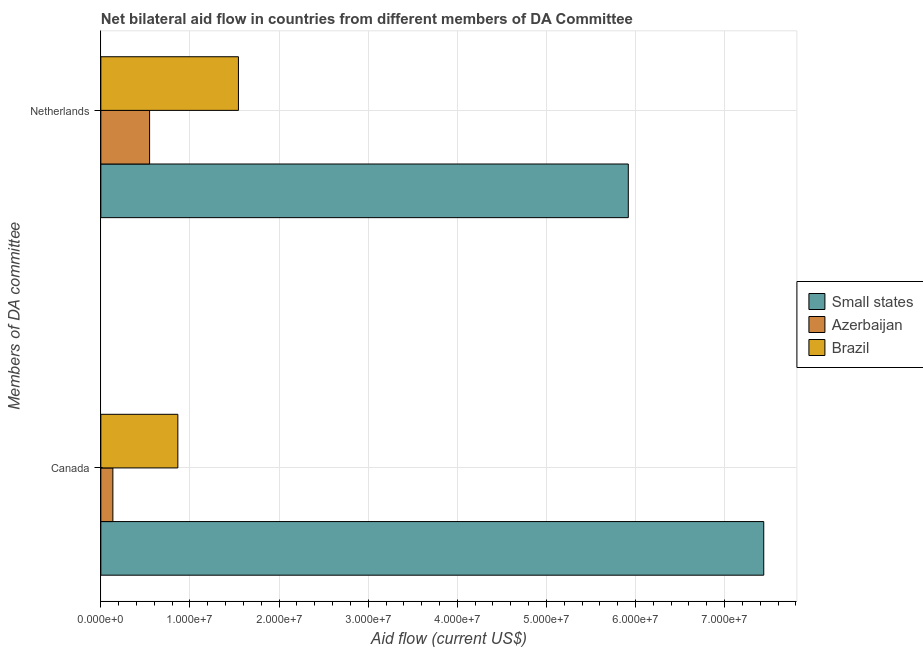Are the number of bars per tick equal to the number of legend labels?
Provide a short and direct response. Yes. Are the number of bars on each tick of the Y-axis equal?
Give a very brief answer. Yes. How many bars are there on the 2nd tick from the bottom?
Your answer should be compact. 3. What is the label of the 1st group of bars from the top?
Offer a terse response. Netherlands. What is the amount of aid given by netherlands in Small states?
Give a very brief answer. 5.92e+07. Across all countries, what is the maximum amount of aid given by netherlands?
Provide a short and direct response. 5.92e+07. Across all countries, what is the minimum amount of aid given by netherlands?
Offer a terse response. 5.47e+06. In which country was the amount of aid given by netherlands maximum?
Ensure brevity in your answer.  Small states. In which country was the amount of aid given by canada minimum?
Offer a terse response. Azerbaijan. What is the total amount of aid given by netherlands in the graph?
Offer a terse response. 8.01e+07. What is the difference between the amount of aid given by netherlands in Azerbaijan and that in Small states?
Your answer should be very brief. -5.37e+07. What is the difference between the amount of aid given by canada in Brazil and the amount of aid given by netherlands in Azerbaijan?
Provide a short and direct response. 3.17e+06. What is the average amount of aid given by canada per country?
Your answer should be very brief. 2.81e+07. What is the difference between the amount of aid given by canada and amount of aid given by netherlands in Azerbaijan?
Offer a very short reply. -4.12e+06. In how many countries, is the amount of aid given by netherlands greater than 26000000 US$?
Your answer should be very brief. 1. What is the ratio of the amount of aid given by canada in Small states to that in Azerbaijan?
Your response must be concise. 55.1. Is the amount of aid given by canada in Brazil less than that in Small states?
Ensure brevity in your answer.  Yes. In how many countries, is the amount of aid given by netherlands greater than the average amount of aid given by netherlands taken over all countries?
Offer a terse response. 1. What does the 2nd bar from the top in Canada represents?
Your response must be concise. Azerbaijan. What does the 2nd bar from the bottom in Canada represents?
Provide a succinct answer. Azerbaijan. How many bars are there?
Keep it short and to the point. 6. What is the difference between two consecutive major ticks on the X-axis?
Keep it short and to the point. 1.00e+07. Are the values on the major ticks of X-axis written in scientific E-notation?
Offer a very short reply. Yes. Where does the legend appear in the graph?
Keep it short and to the point. Center right. How are the legend labels stacked?
Ensure brevity in your answer.  Vertical. What is the title of the graph?
Make the answer very short. Net bilateral aid flow in countries from different members of DA Committee. What is the label or title of the Y-axis?
Your answer should be very brief. Members of DA committee. What is the Aid flow (current US$) in Small states in Canada?
Your answer should be compact. 7.44e+07. What is the Aid flow (current US$) in Azerbaijan in Canada?
Ensure brevity in your answer.  1.35e+06. What is the Aid flow (current US$) of Brazil in Canada?
Provide a succinct answer. 8.64e+06. What is the Aid flow (current US$) in Small states in Netherlands?
Your answer should be compact. 5.92e+07. What is the Aid flow (current US$) of Azerbaijan in Netherlands?
Offer a terse response. 5.47e+06. What is the Aid flow (current US$) in Brazil in Netherlands?
Provide a succinct answer. 1.54e+07. Across all Members of DA committee, what is the maximum Aid flow (current US$) of Small states?
Offer a terse response. 7.44e+07. Across all Members of DA committee, what is the maximum Aid flow (current US$) of Azerbaijan?
Keep it short and to the point. 5.47e+06. Across all Members of DA committee, what is the maximum Aid flow (current US$) of Brazil?
Offer a terse response. 1.54e+07. Across all Members of DA committee, what is the minimum Aid flow (current US$) of Small states?
Provide a short and direct response. 5.92e+07. Across all Members of DA committee, what is the minimum Aid flow (current US$) in Azerbaijan?
Provide a short and direct response. 1.35e+06. Across all Members of DA committee, what is the minimum Aid flow (current US$) in Brazil?
Your response must be concise. 8.64e+06. What is the total Aid flow (current US$) in Small states in the graph?
Your answer should be compact. 1.34e+08. What is the total Aid flow (current US$) of Azerbaijan in the graph?
Provide a short and direct response. 6.82e+06. What is the total Aid flow (current US$) in Brazil in the graph?
Give a very brief answer. 2.41e+07. What is the difference between the Aid flow (current US$) in Small states in Canada and that in Netherlands?
Keep it short and to the point. 1.52e+07. What is the difference between the Aid flow (current US$) in Azerbaijan in Canada and that in Netherlands?
Your answer should be very brief. -4.12e+06. What is the difference between the Aid flow (current US$) in Brazil in Canada and that in Netherlands?
Your answer should be compact. -6.80e+06. What is the difference between the Aid flow (current US$) of Small states in Canada and the Aid flow (current US$) of Azerbaijan in Netherlands?
Offer a terse response. 6.89e+07. What is the difference between the Aid flow (current US$) in Small states in Canada and the Aid flow (current US$) in Brazil in Netherlands?
Your answer should be very brief. 5.90e+07. What is the difference between the Aid flow (current US$) of Azerbaijan in Canada and the Aid flow (current US$) of Brazil in Netherlands?
Provide a succinct answer. -1.41e+07. What is the average Aid flow (current US$) of Small states per Members of DA committee?
Your answer should be compact. 6.68e+07. What is the average Aid flow (current US$) of Azerbaijan per Members of DA committee?
Make the answer very short. 3.41e+06. What is the average Aid flow (current US$) in Brazil per Members of DA committee?
Your answer should be very brief. 1.20e+07. What is the difference between the Aid flow (current US$) of Small states and Aid flow (current US$) of Azerbaijan in Canada?
Your answer should be compact. 7.30e+07. What is the difference between the Aid flow (current US$) of Small states and Aid flow (current US$) of Brazil in Canada?
Your answer should be very brief. 6.58e+07. What is the difference between the Aid flow (current US$) in Azerbaijan and Aid flow (current US$) in Brazil in Canada?
Provide a succinct answer. -7.29e+06. What is the difference between the Aid flow (current US$) in Small states and Aid flow (current US$) in Azerbaijan in Netherlands?
Your response must be concise. 5.37e+07. What is the difference between the Aid flow (current US$) in Small states and Aid flow (current US$) in Brazil in Netherlands?
Offer a terse response. 4.38e+07. What is the difference between the Aid flow (current US$) of Azerbaijan and Aid flow (current US$) of Brazil in Netherlands?
Give a very brief answer. -9.97e+06. What is the ratio of the Aid flow (current US$) in Small states in Canada to that in Netherlands?
Keep it short and to the point. 1.26. What is the ratio of the Aid flow (current US$) in Azerbaijan in Canada to that in Netherlands?
Offer a very short reply. 0.25. What is the ratio of the Aid flow (current US$) in Brazil in Canada to that in Netherlands?
Your response must be concise. 0.56. What is the difference between the highest and the second highest Aid flow (current US$) in Small states?
Your answer should be very brief. 1.52e+07. What is the difference between the highest and the second highest Aid flow (current US$) of Azerbaijan?
Offer a very short reply. 4.12e+06. What is the difference between the highest and the second highest Aid flow (current US$) in Brazil?
Give a very brief answer. 6.80e+06. What is the difference between the highest and the lowest Aid flow (current US$) of Small states?
Make the answer very short. 1.52e+07. What is the difference between the highest and the lowest Aid flow (current US$) in Azerbaijan?
Offer a very short reply. 4.12e+06. What is the difference between the highest and the lowest Aid flow (current US$) in Brazil?
Your answer should be very brief. 6.80e+06. 